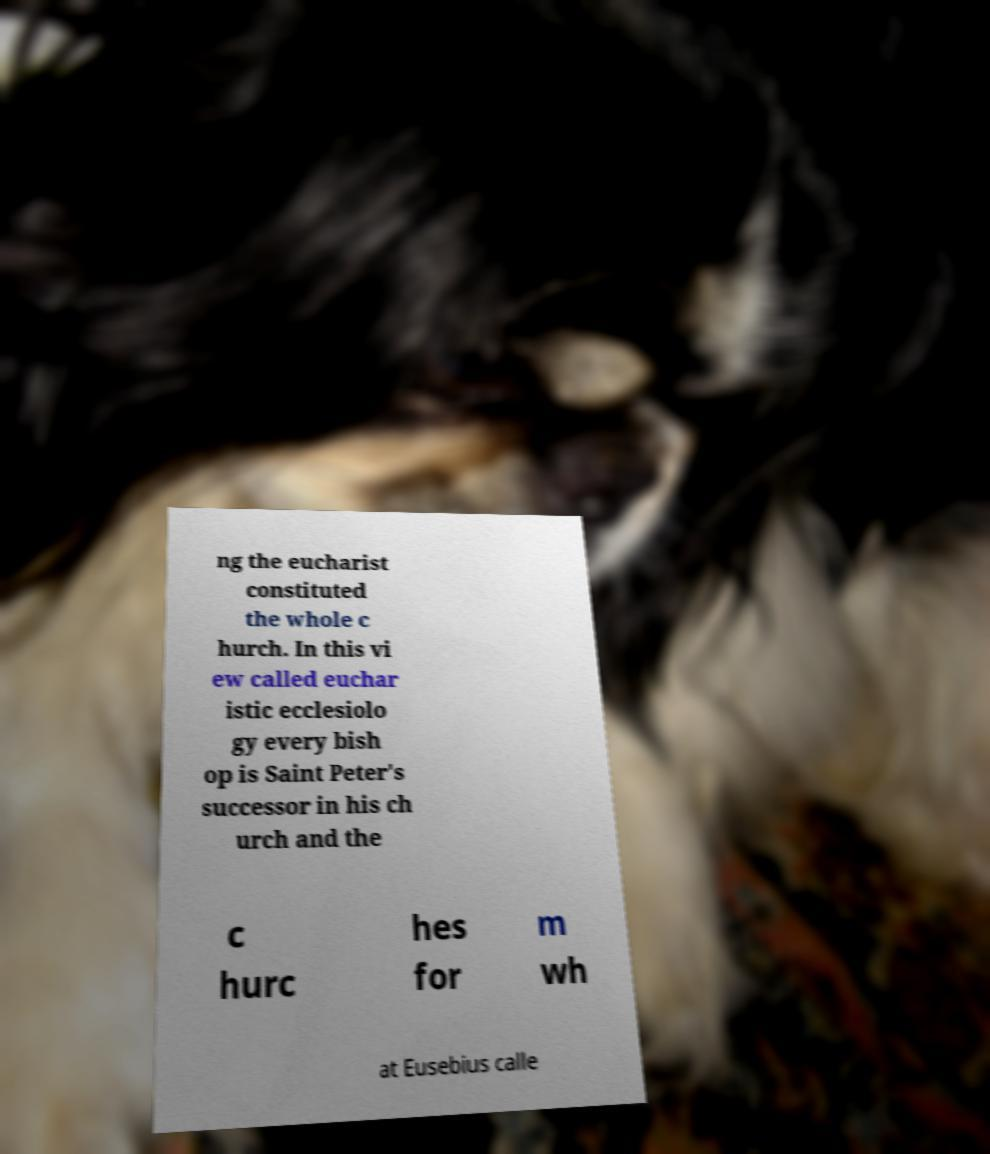Could you assist in decoding the text presented in this image and type it out clearly? ng the eucharist constituted the whole c hurch. In this vi ew called euchar istic ecclesiolo gy every bish op is Saint Peter's successor in his ch urch and the c hurc hes for m wh at Eusebius calle 